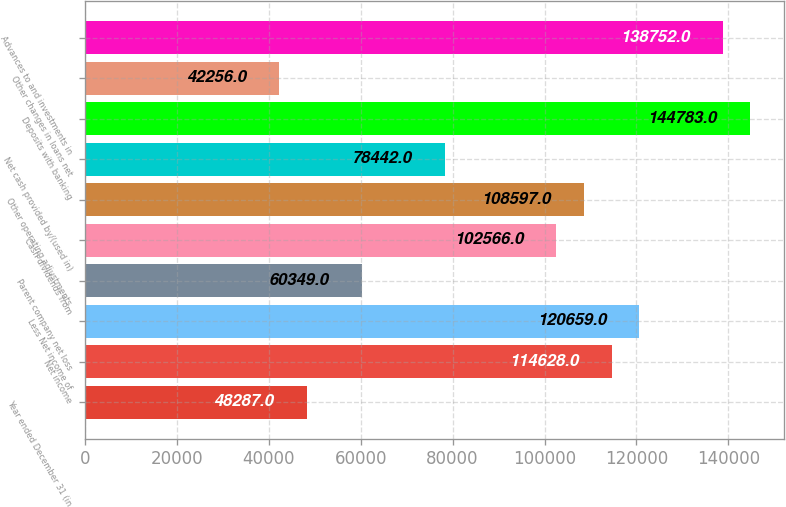Convert chart to OTSL. <chart><loc_0><loc_0><loc_500><loc_500><bar_chart><fcel>Year ended December 31 (in<fcel>Net income<fcel>Less Net income of<fcel>Parent company net loss<fcel>Cash dividends from<fcel>Other operating adjustments<fcel>Net cash provided by/(used in)<fcel>Deposits with banking<fcel>Other changes in loans net<fcel>Advances to and investments in<nl><fcel>48287<fcel>114628<fcel>120659<fcel>60349<fcel>102566<fcel>108597<fcel>78442<fcel>144783<fcel>42256<fcel>138752<nl></chart> 